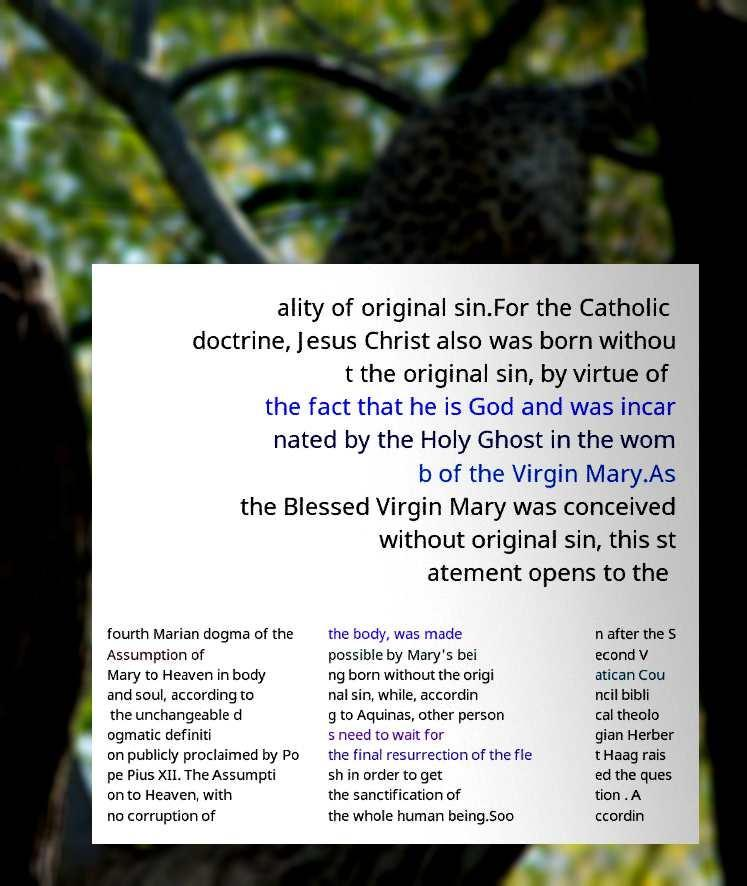For documentation purposes, I need the text within this image transcribed. Could you provide that? ality of original sin.For the Catholic doctrine, Jesus Christ also was born withou t the original sin, by virtue of the fact that he is God and was incar nated by the Holy Ghost in the wom b of the Virgin Mary.As the Blessed Virgin Mary was conceived without original sin, this st atement opens to the fourth Marian dogma of the Assumption of Mary to Heaven in body and soul, according to the unchangeable d ogmatic definiti on publicly proclaimed by Po pe Pius XII. The Assumpti on to Heaven, with no corruption of the body, was made possible by Mary's bei ng born without the origi nal sin, while, accordin g to Aquinas, other person s need to wait for the final resurrection of the fle sh in order to get the sanctification of the whole human being.Soo n after the S econd V atican Cou ncil bibli cal theolo gian Herber t Haag rais ed the ques tion . A ccordin 